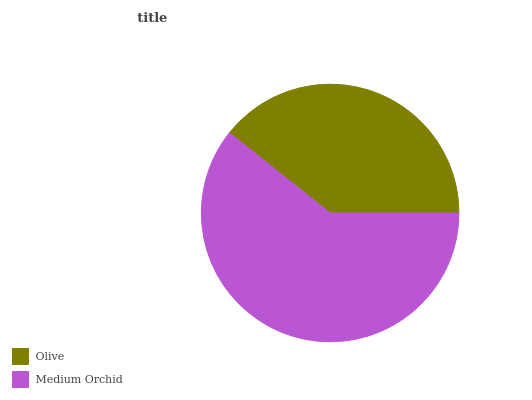Is Olive the minimum?
Answer yes or no. Yes. Is Medium Orchid the maximum?
Answer yes or no. Yes. Is Medium Orchid the minimum?
Answer yes or no. No. Is Medium Orchid greater than Olive?
Answer yes or no. Yes. Is Olive less than Medium Orchid?
Answer yes or no. Yes. Is Olive greater than Medium Orchid?
Answer yes or no. No. Is Medium Orchid less than Olive?
Answer yes or no. No. Is Medium Orchid the high median?
Answer yes or no. Yes. Is Olive the low median?
Answer yes or no. Yes. Is Olive the high median?
Answer yes or no. No. Is Medium Orchid the low median?
Answer yes or no. No. 